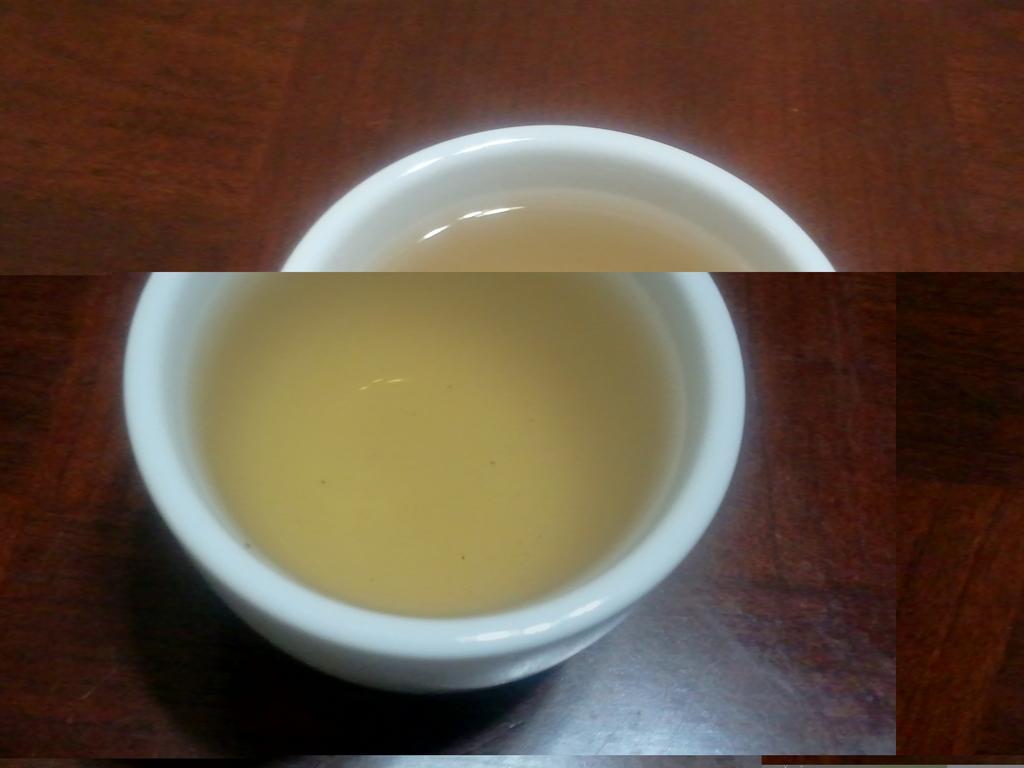How would you summarize this image in a sentence or two? This is a collage image, in this image there is table on that table there is a cup, in that cup there is liquid. 